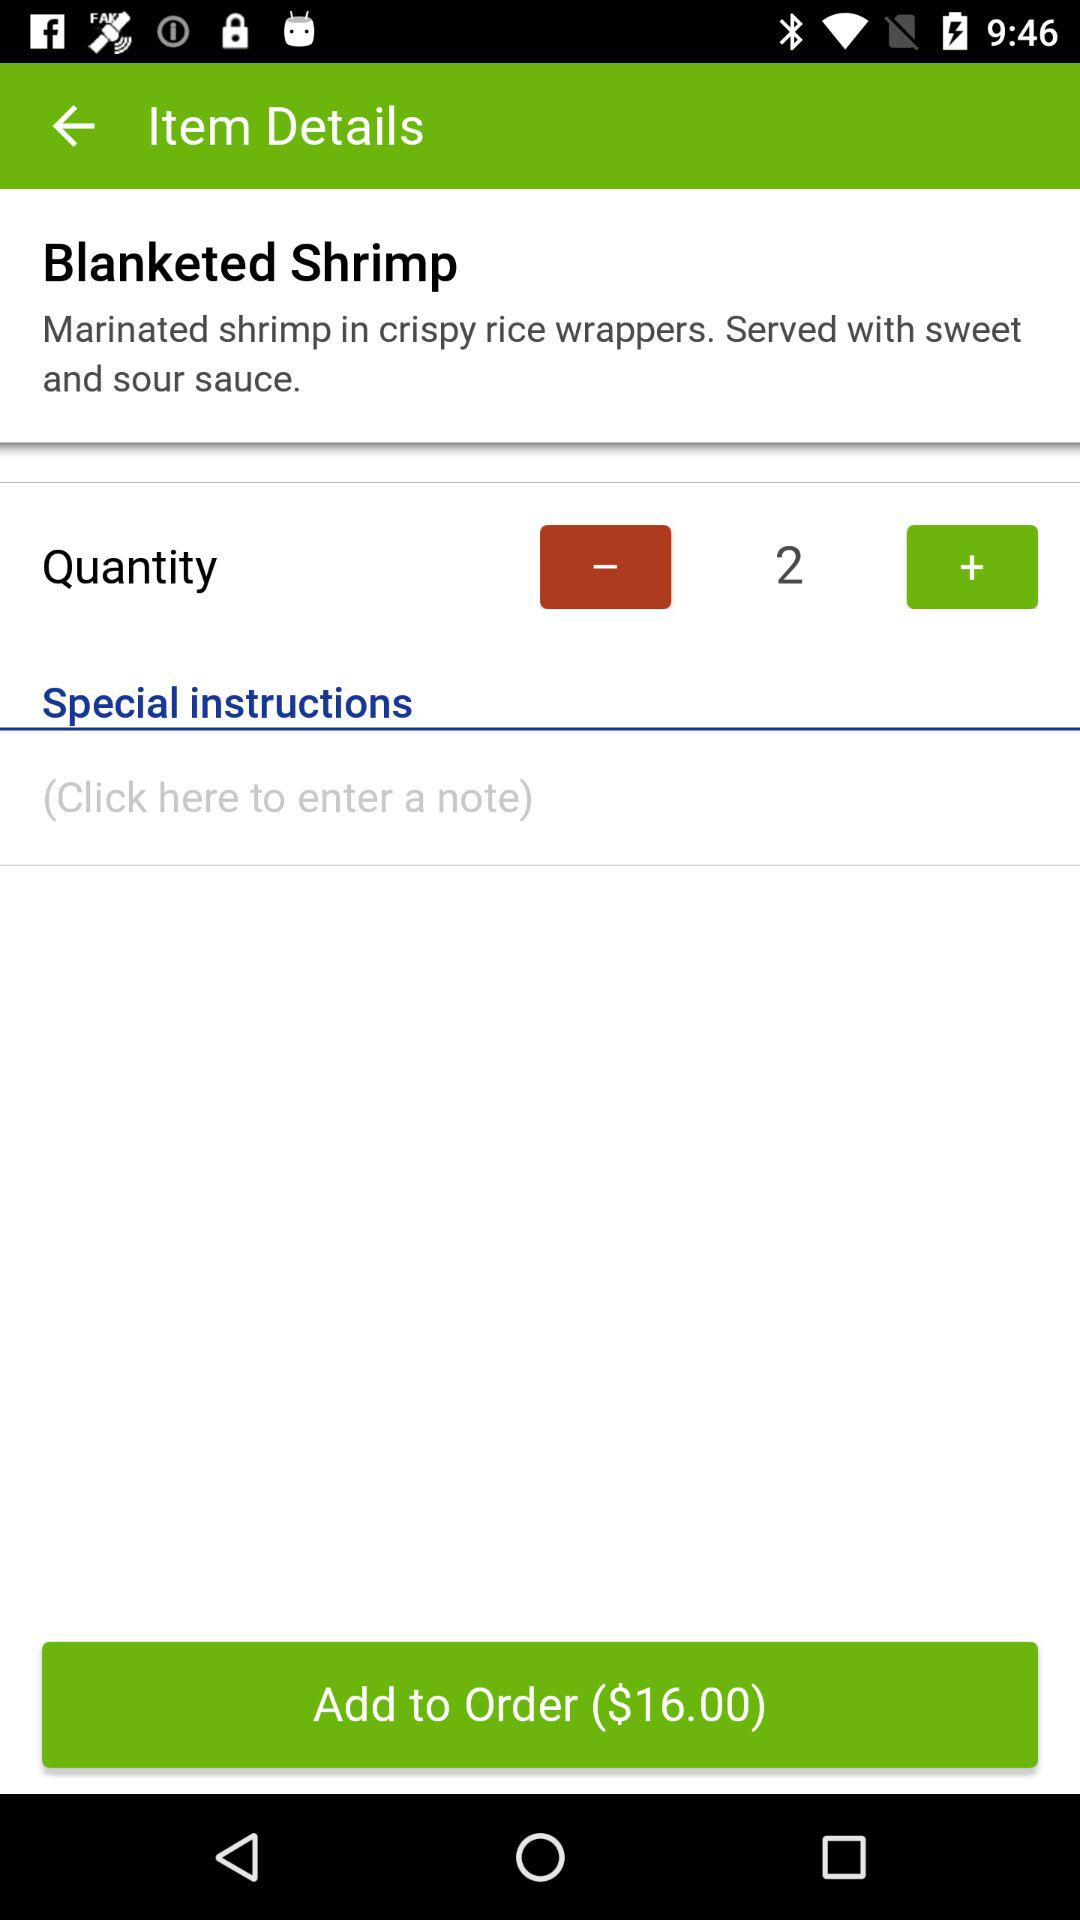How many Blanketed Shrimp are in the order?
Answer the question using a single word or phrase. 2 